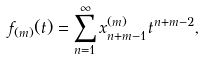<formula> <loc_0><loc_0><loc_500><loc_500>f _ { ( m ) } ( t ) = \sum _ { n = 1 } ^ { \infty } x _ { n + m - 1 } ^ { ( m ) } t ^ { n + m - 2 } ,</formula> 